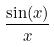Convert formula to latex. <formula><loc_0><loc_0><loc_500><loc_500>\frac { \sin ( x ) } { x }</formula> 